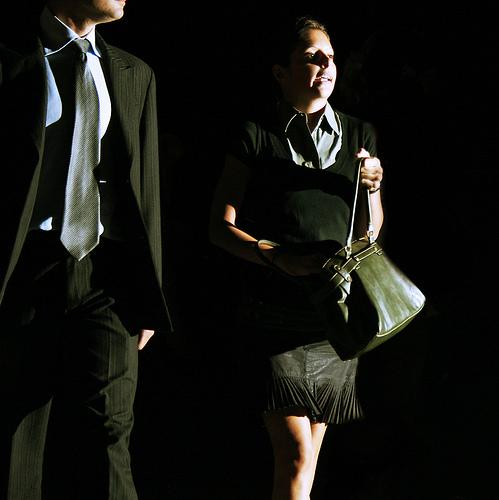What is the person on the left wearing?

Choices:
A) tie
B) cat ears
C) suspenders
D) crown tie 